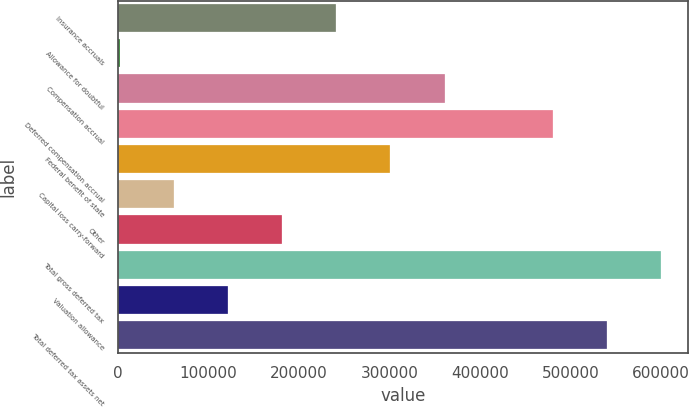<chart> <loc_0><loc_0><loc_500><loc_500><bar_chart><fcel>Insurance accruals<fcel>Allowance for doubtful<fcel>Compensation accrual<fcel>Deferred compensation accrual<fcel>Federal benefit of state<fcel>Capital loss carry-forward<fcel>Other<fcel>Total gross deferred tax<fcel>Valuation allowance<fcel>Total deferred tax assets net<nl><fcel>241064<fcel>1715<fcel>360738<fcel>480413<fcel>300901<fcel>61552.2<fcel>181227<fcel>600087<fcel>121389<fcel>540250<nl></chart> 